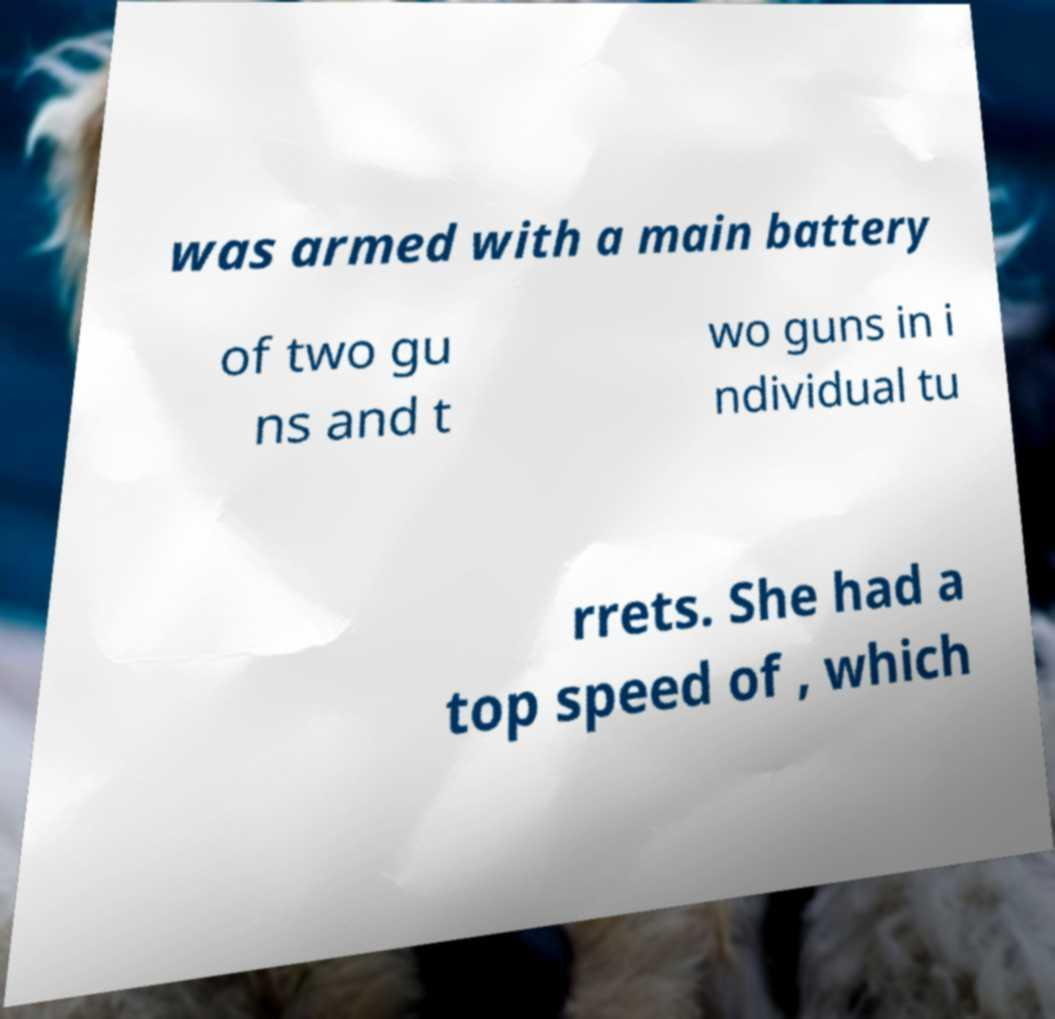I need the written content from this picture converted into text. Can you do that? was armed with a main battery of two gu ns and t wo guns in i ndividual tu rrets. She had a top speed of , which 